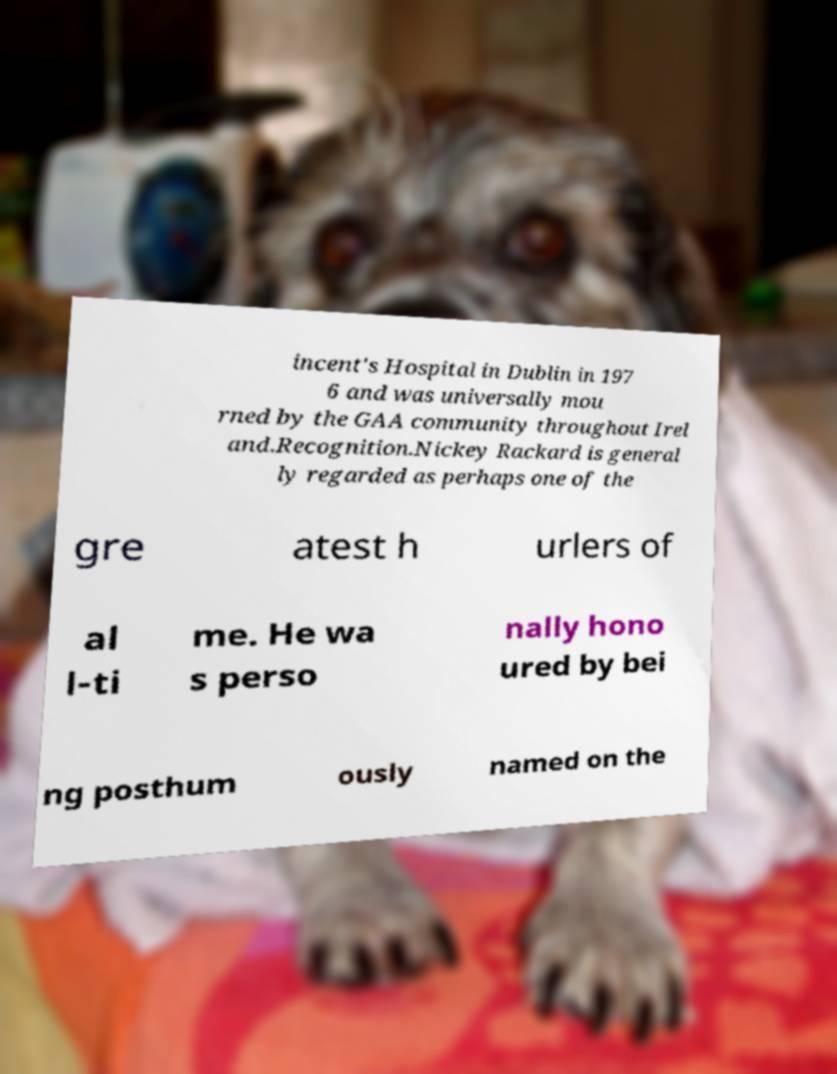Can you read and provide the text displayed in the image?This photo seems to have some interesting text. Can you extract and type it out for me? incent's Hospital in Dublin in 197 6 and was universally mou rned by the GAA community throughout Irel and.Recognition.Nickey Rackard is general ly regarded as perhaps one of the gre atest h urlers of al l-ti me. He wa s perso nally hono ured by bei ng posthum ously named on the 